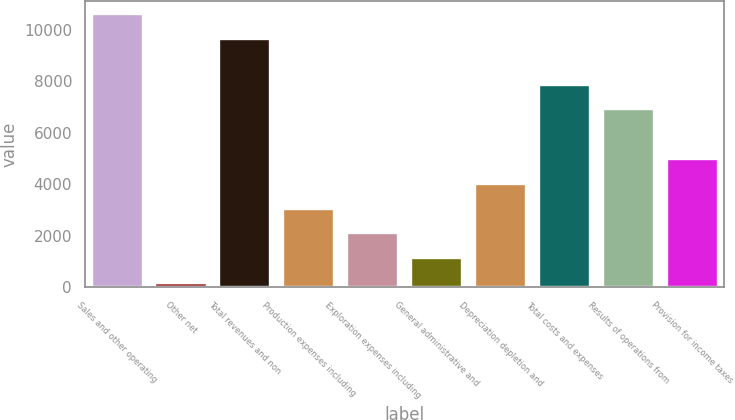Convert chart. <chart><loc_0><loc_0><loc_500><loc_500><bar_chart><fcel>Sales and other operating<fcel>Other net<fcel>Total revenues and non<fcel>Production expenses including<fcel>Exploration expenses including<fcel>General administrative and<fcel>Depreciation depletion and<fcel>Total costs and expenses<fcel>Results of operations from<fcel>Provision for income taxes<nl><fcel>10602.9<fcel>167<fcel>9639<fcel>3058.7<fcel>2094.8<fcel>1130.9<fcel>4022.6<fcel>7878.2<fcel>6914.3<fcel>4986.5<nl></chart> 